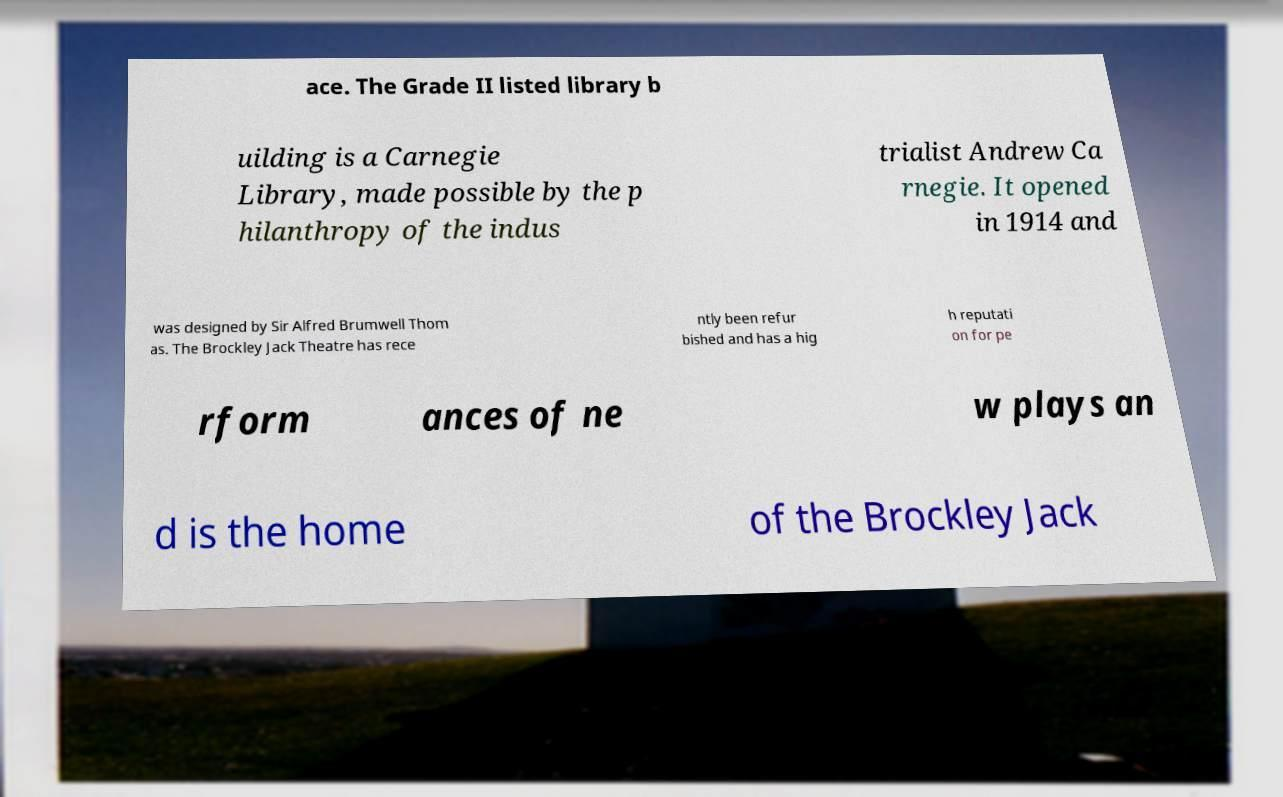What messages or text are displayed in this image? I need them in a readable, typed format. ace. The Grade II listed library b uilding is a Carnegie Library, made possible by the p hilanthropy of the indus trialist Andrew Ca rnegie. It opened in 1914 and was designed by Sir Alfred Brumwell Thom as. The Brockley Jack Theatre has rece ntly been refur bished and has a hig h reputati on for pe rform ances of ne w plays an d is the home of the Brockley Jack 